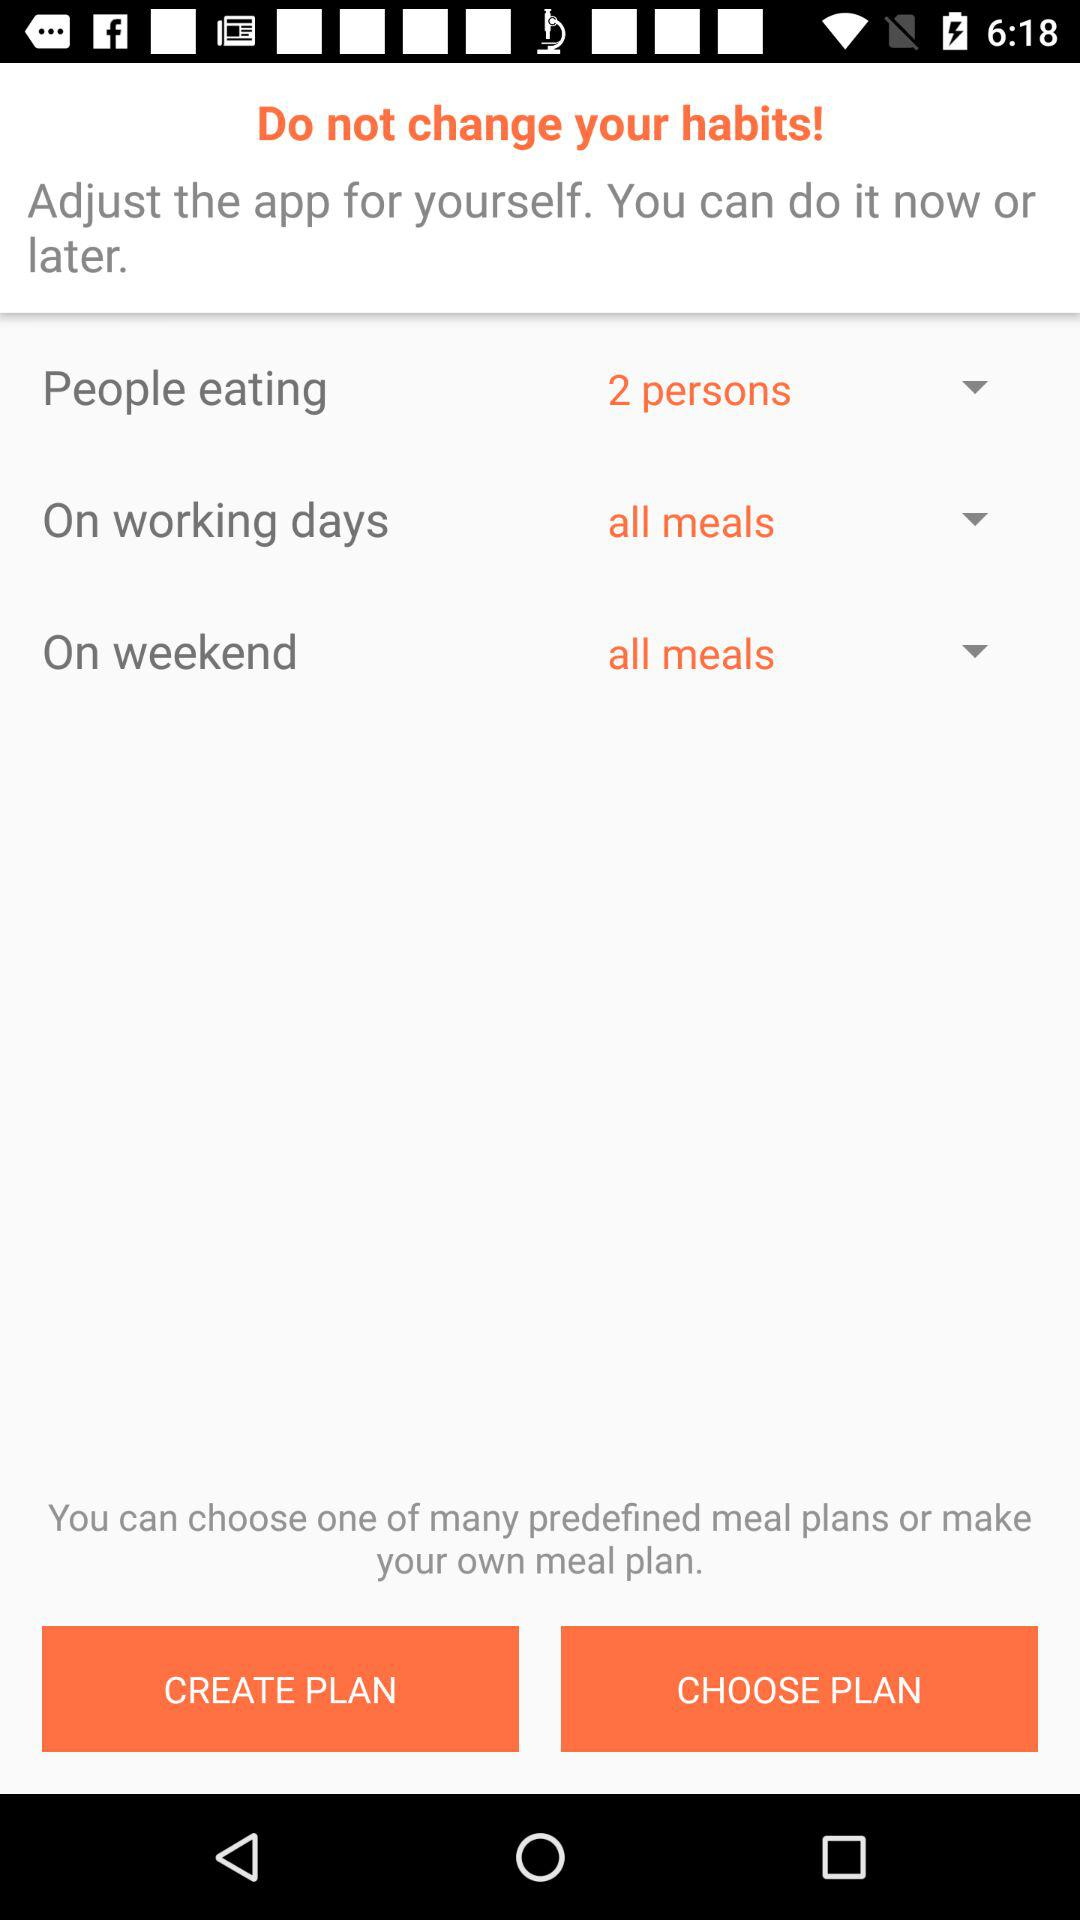How many people are there on the meal plan?
Answer the question using a single word or phrase. 2 